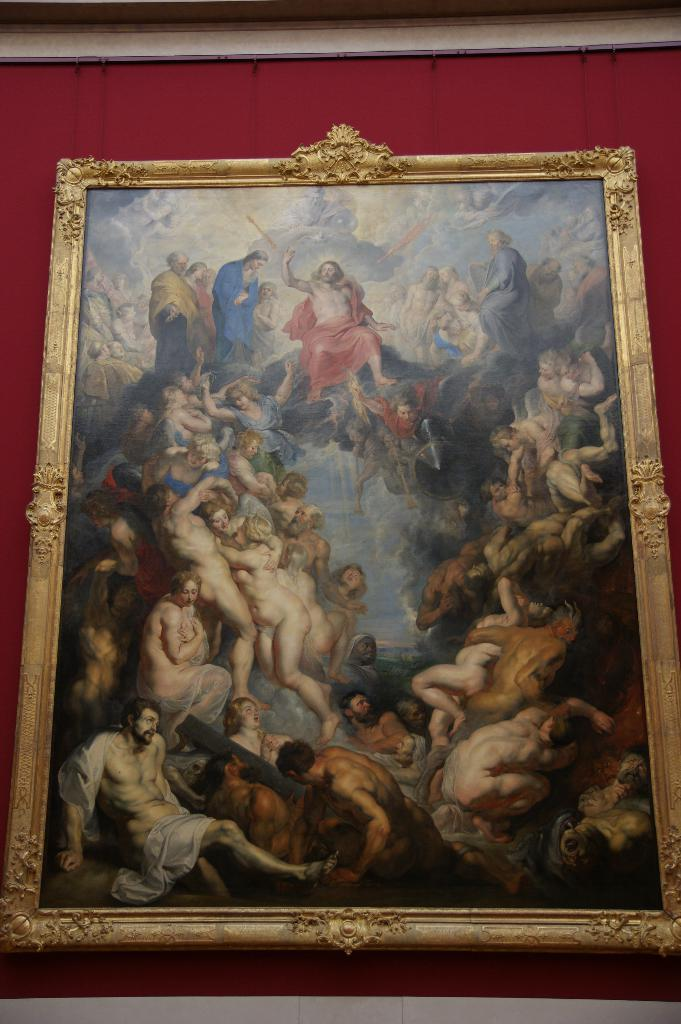What is the main object in the image? There is a frame in the image. What can be seen inside the frame? The frame contains a few people. Where is the frame located in the image? The frame is hanging on the wall. What type of spoon is being used by the people in the frame? There is no spoon present in the image, as it only shows a frame hanging on the wall with a few people inside. 